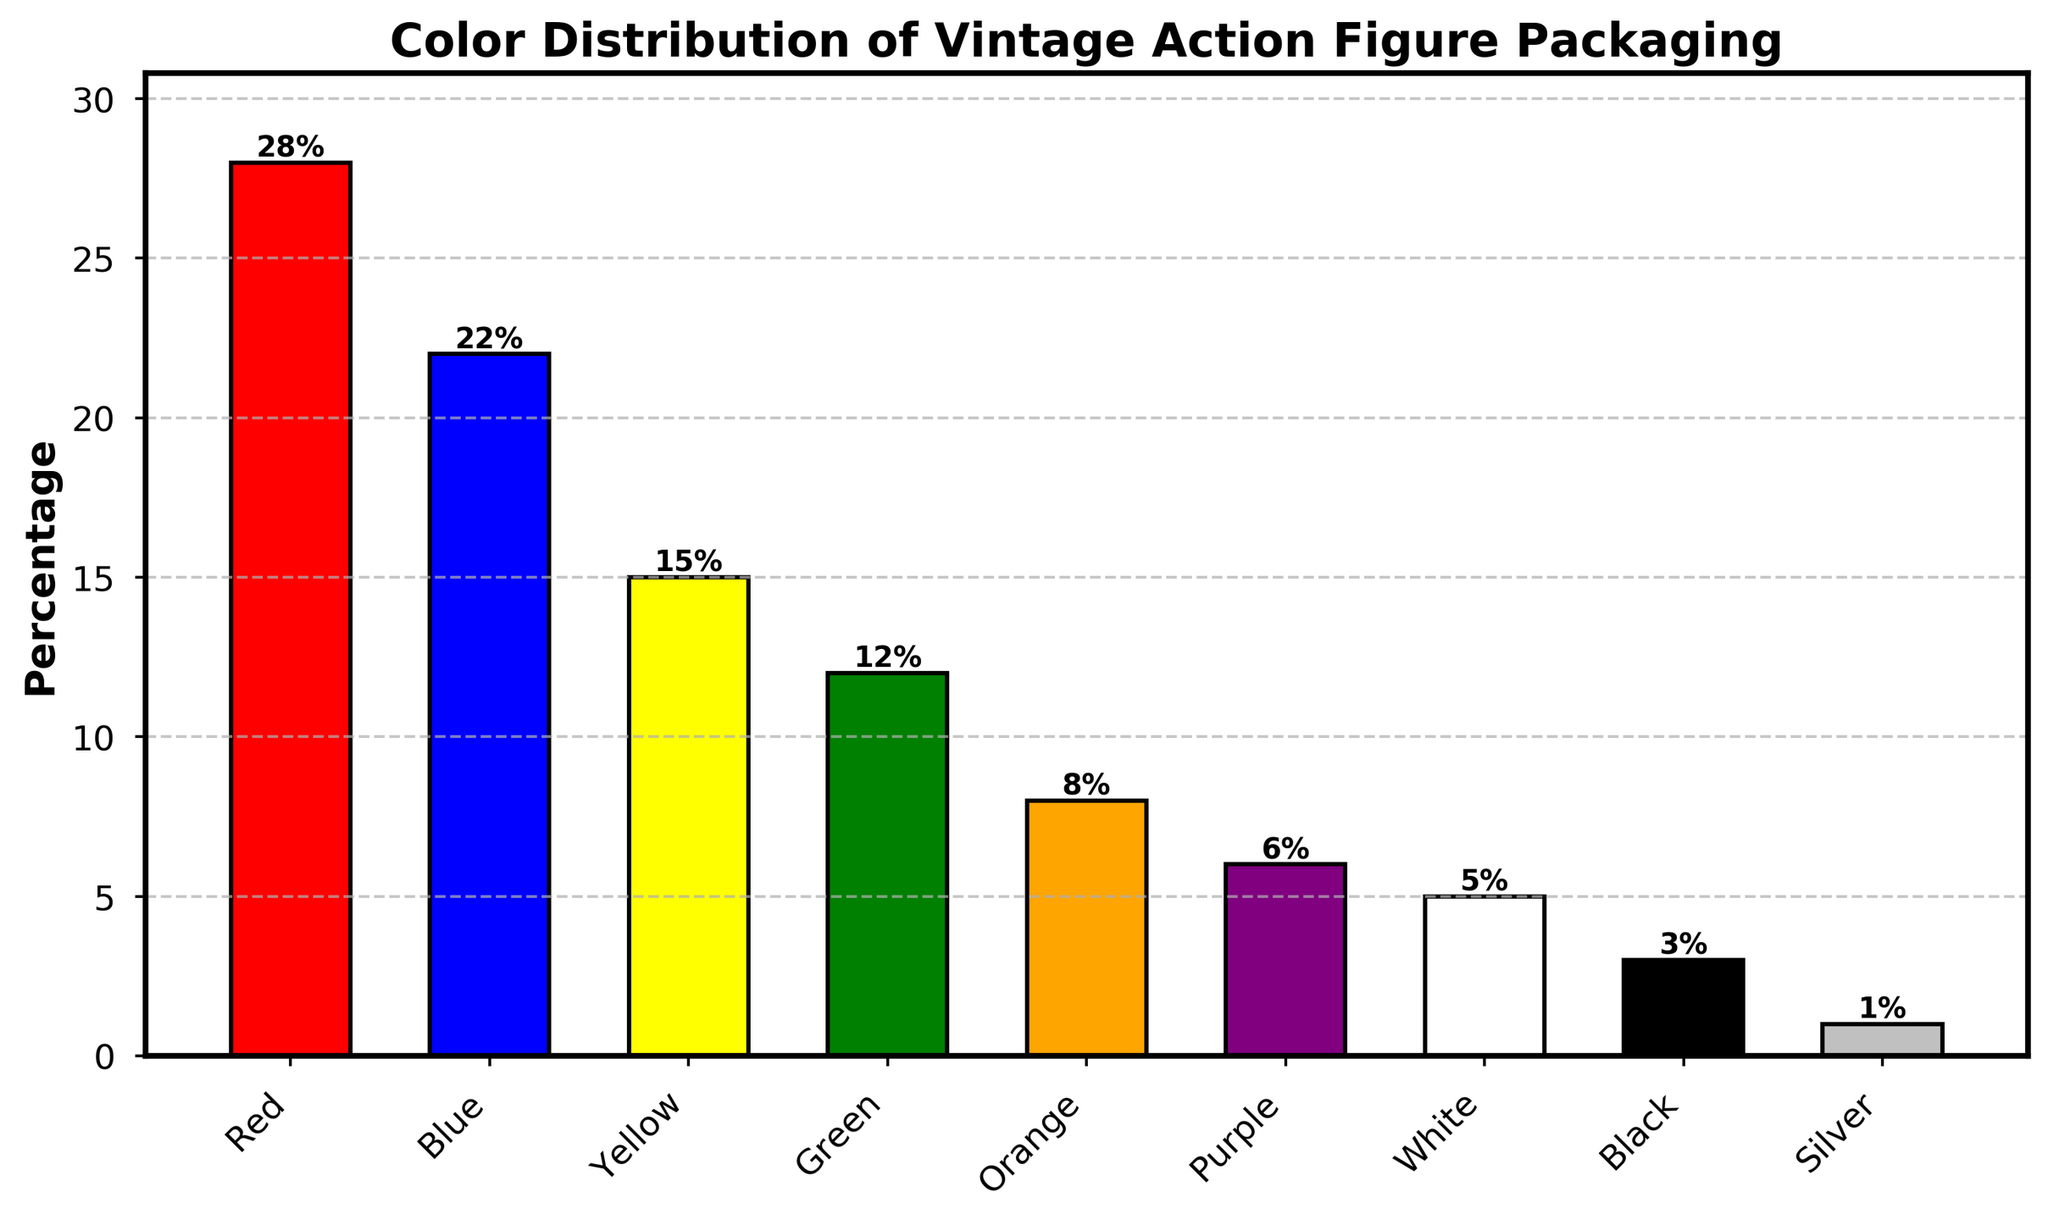Which color has the highest percentage of action figure packaging? The bar representing the color red is the tallest, showing the highest percentage value.
Answer: Red What percentage of action figure packaging is Green or White? Green has a percentage of 12% and White has a percentage of 5%. Adding these together: 12% + 5% = 17%.
Answer: 17% How much higher is the percentage of Red packaging compared to Black packaging? Red has a percentage of 28% while Black has 3%. The difference is calculated as 28% - 3% = 25%.
Answer: 25% Which two colors have the closest percentage values? Blue has 22% and Yellow has 15%. The difference is 22% - 15% = 7%. However, Green has 12% and Orange has 8%, with a difference of 4%, which is closer.
Answer: Green and Orange What is the sum of the percentages of the least common colors? The least common colors are Black (3%) and Silver (1%). Adding these together: 3% + 1% = 4%.
Answer: 4% Does Blue have a higher percentage than Yellow and Orange combined? Blue has a percentage of 22%. Yellow has 15% and Orange has 8%. Combined, Yellow and Orange have 15% + 8% = 23%. Since 22% is less than 23%, Blue does not have a higher percentage.
Answer: No What is the median percentage value of all the color percentages? The sorted list of percentages is [1, 3, 5, 6, 8, 12, 15, 22, 28]. The middle value in this list is the median, which corresponds to the 5th value: 8%.
Answer: 8% By how much does the Orange percentage exceed the Purple percentage? Orange has 8% and Purple has 6%. The difference is 8% - 6% = 2%.
Answer: 2% 